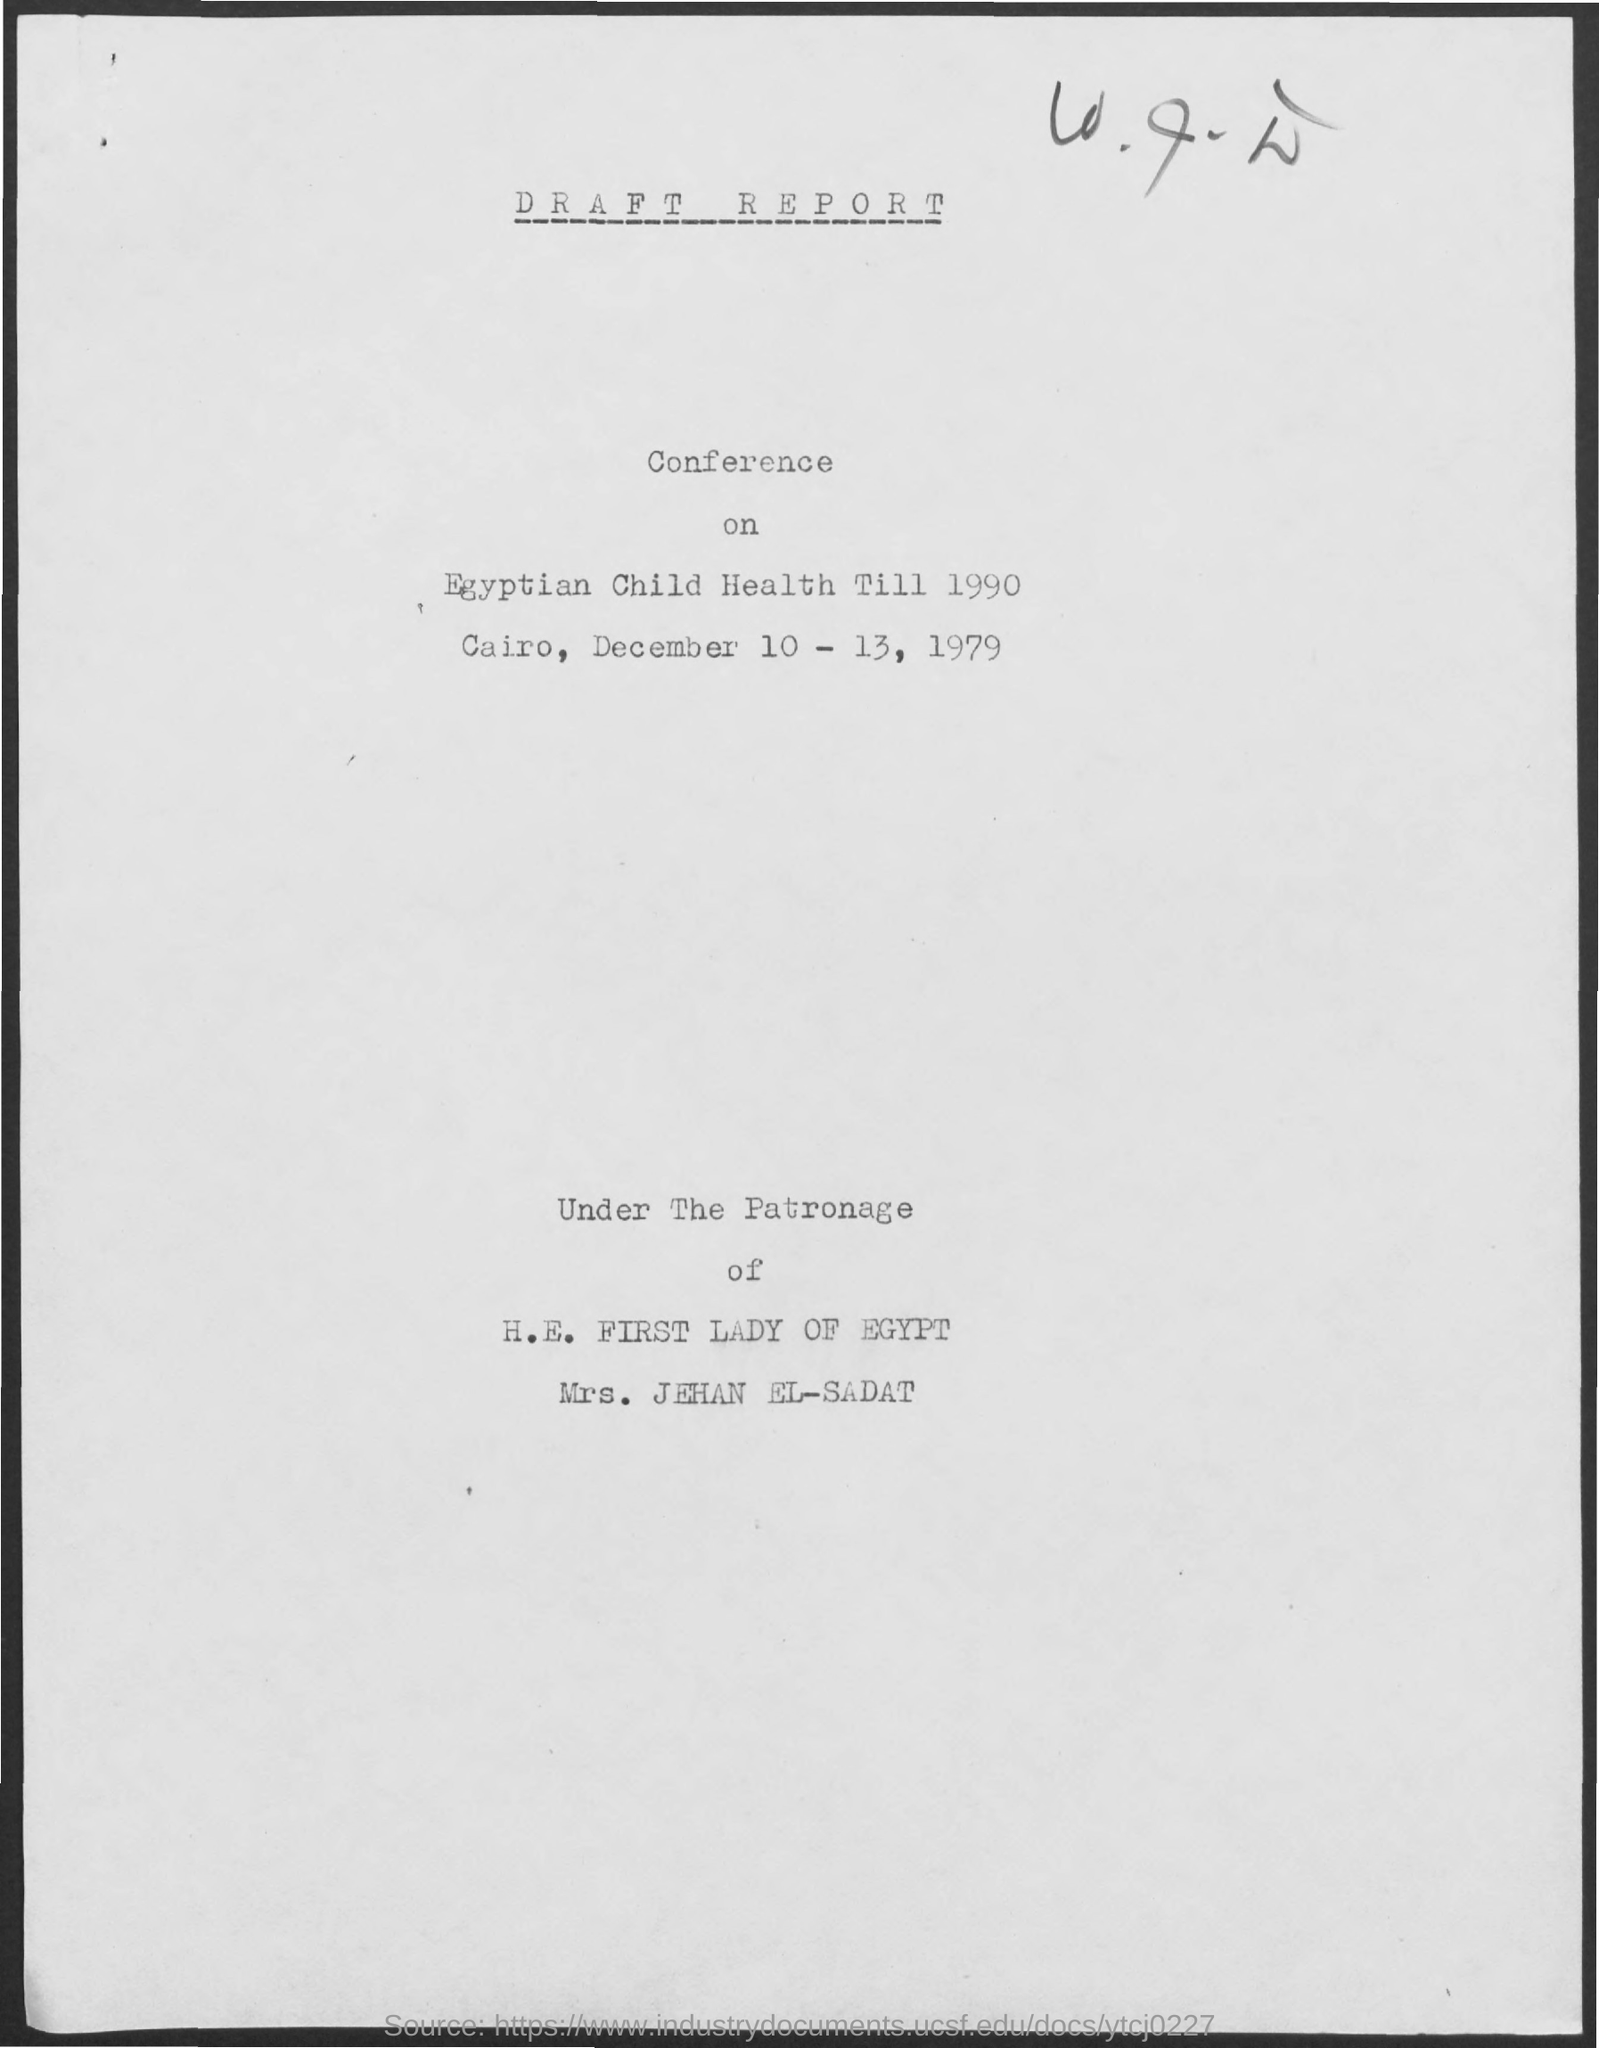Mention a couple of crucial points in this snapshot. The conference will take place from December 10th to December 13th, 1979. The conference is taking place in Cairo. 